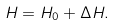<formula> <loc_0><loc_0><loc_500><loc_500>H = H _ { 0 } + \Delta H .</formula> 